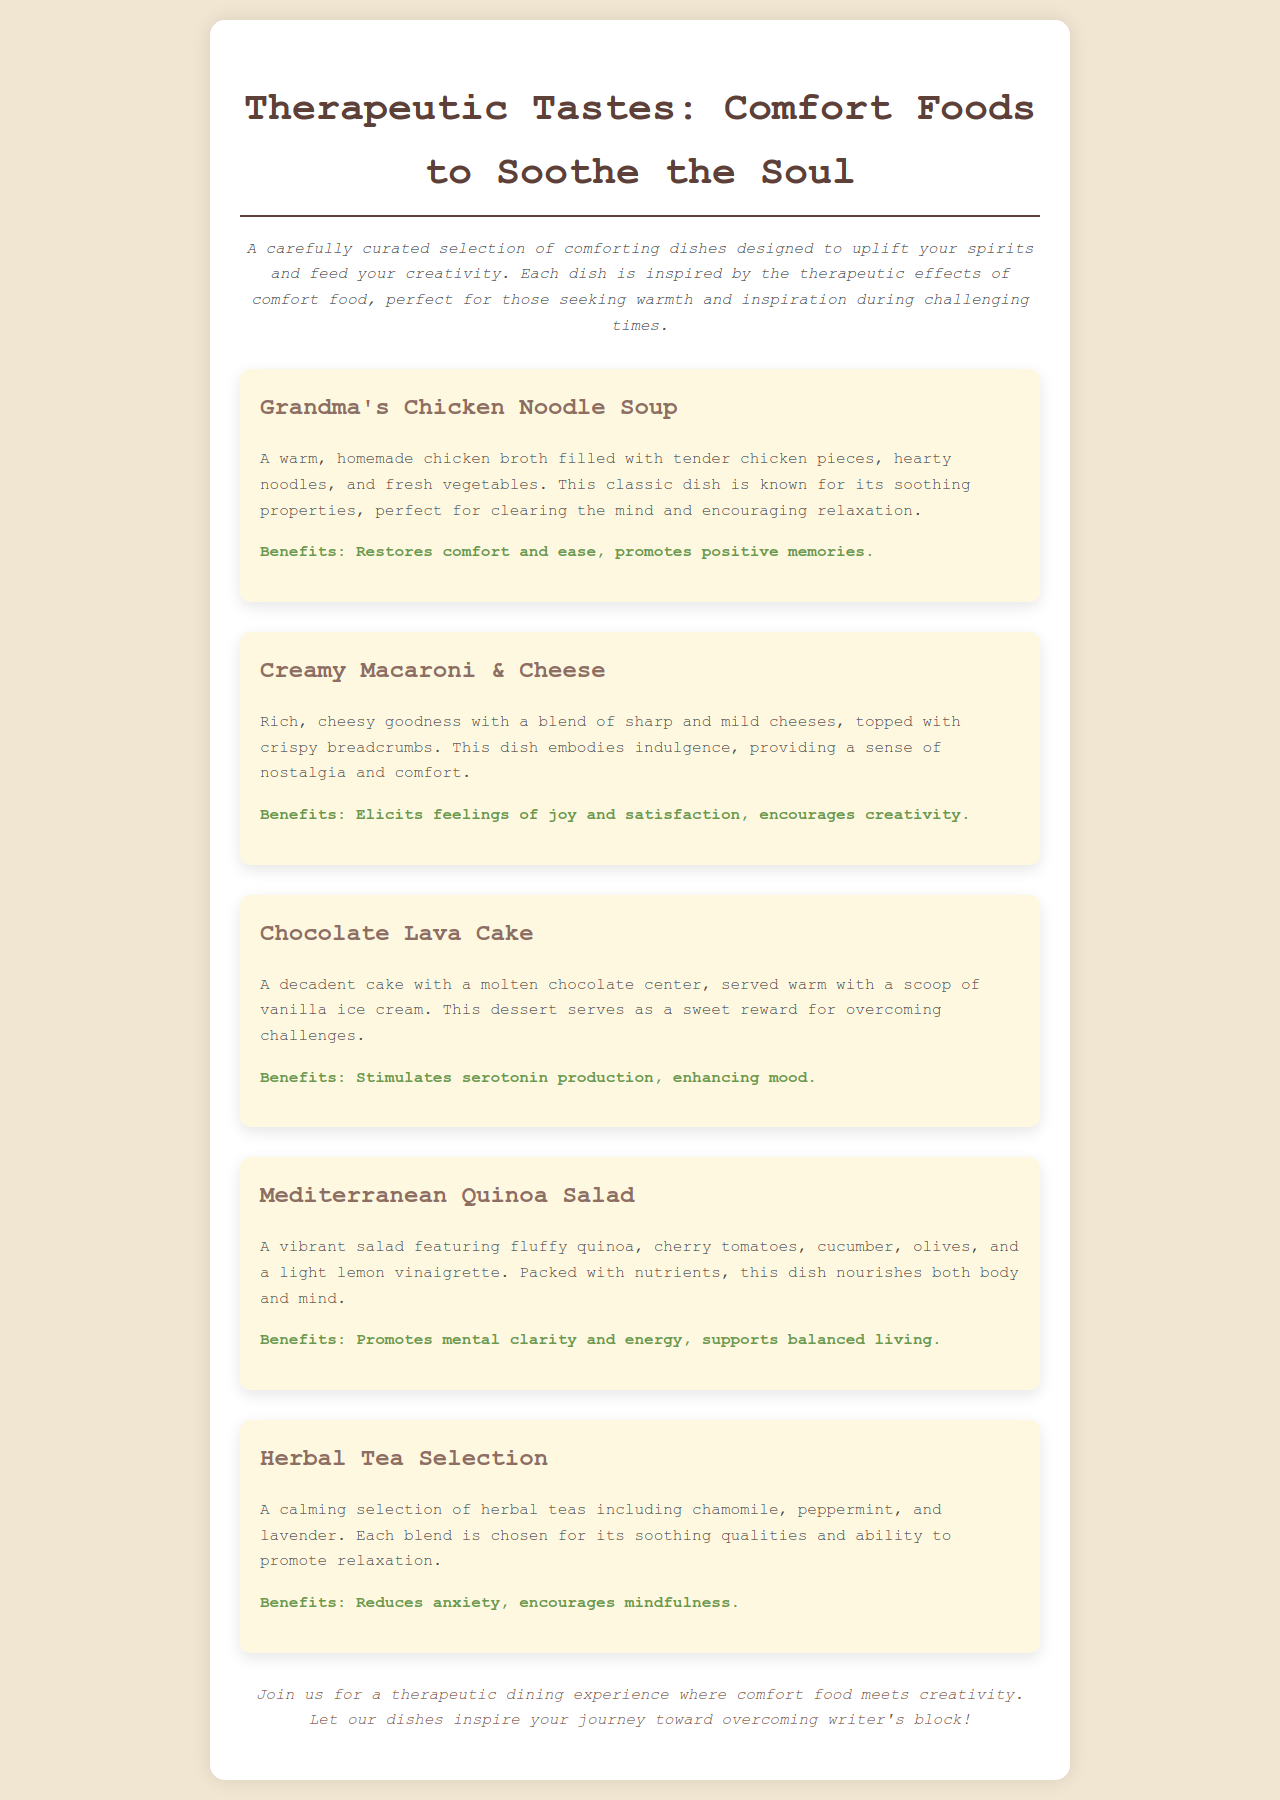What is the title of the menu? The title of the menu is prominently displayed at the top of the document, indicating the theme of the offerings.
Answer: Therapeutic Tastes: Comfort Foods to Soothe the Soul What dish is known for its soothing properties? The document describes several dishes, but specifically highlights a certain one that is well-known for its comforting effects.
Answer: Grandma's Chicken Noodle Soup What dessert is mentioned in the menu? The document features a dedicated section on baked goods, specifying a particular dessert that stands out.
Answer: Chocolate Lava Cake How many herbal tea options are included in the menu? The menu item highlights that a selection of herbal teas is provided but does not specify the count. However, one can infer this based on the text provided.
Answer: Three What is the benefit of the Creamy Macaroni & Cheese? The document lists the positive effects associated with this dish, focusing on emotional responses and creativity.
Answer: Elicits feelings of joy and satisfaction, encourages creativity What ingredients are in the Mediterranean Quinoa Salad? The ingredients are outlined in the description, giving insight into the salad's composition.
Answer: Quinoa, cherry tomatoes, cucumber, olives What type of experience does the menu invite customers to join? There is a strong emphasis in the footer encouraging customers to partake in a specific kind of dining experience offered by the restaurant.
Answer: Therapeutic dining experience What type of cuisine is highlighted in this menu? The overall theme and specific dishes reflect a particular cultural or emotional cuisine that the restaurant wants to convey.
Answer: Comfort food 